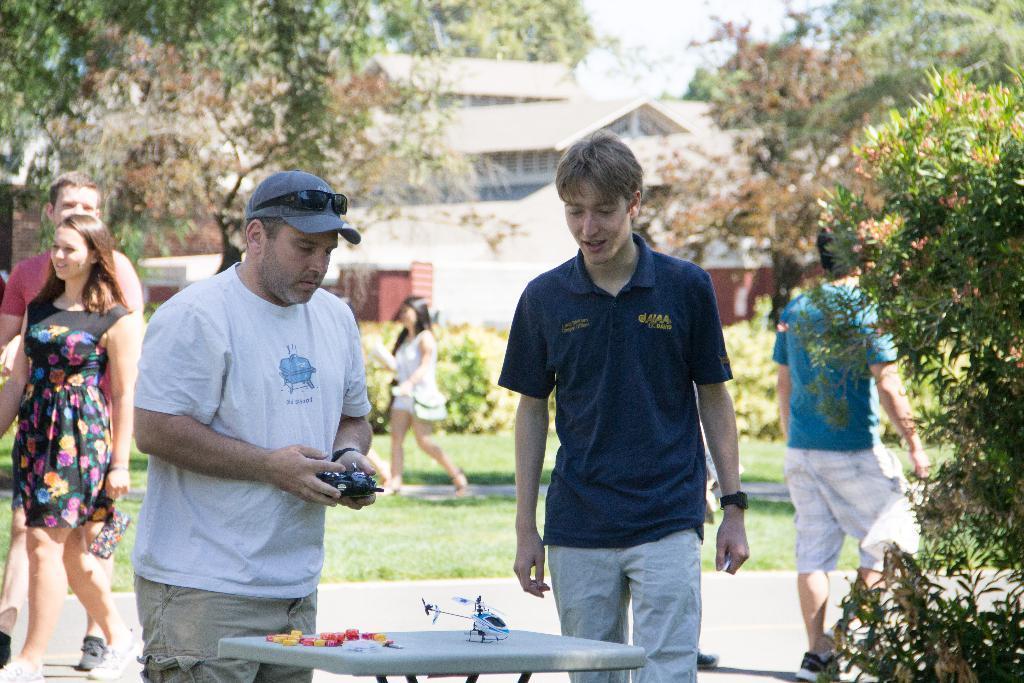Could you give a brief overview of what you see in this image? As we can see in the image there is grass, plants, trees, few people here and there, table, houses and sky. 